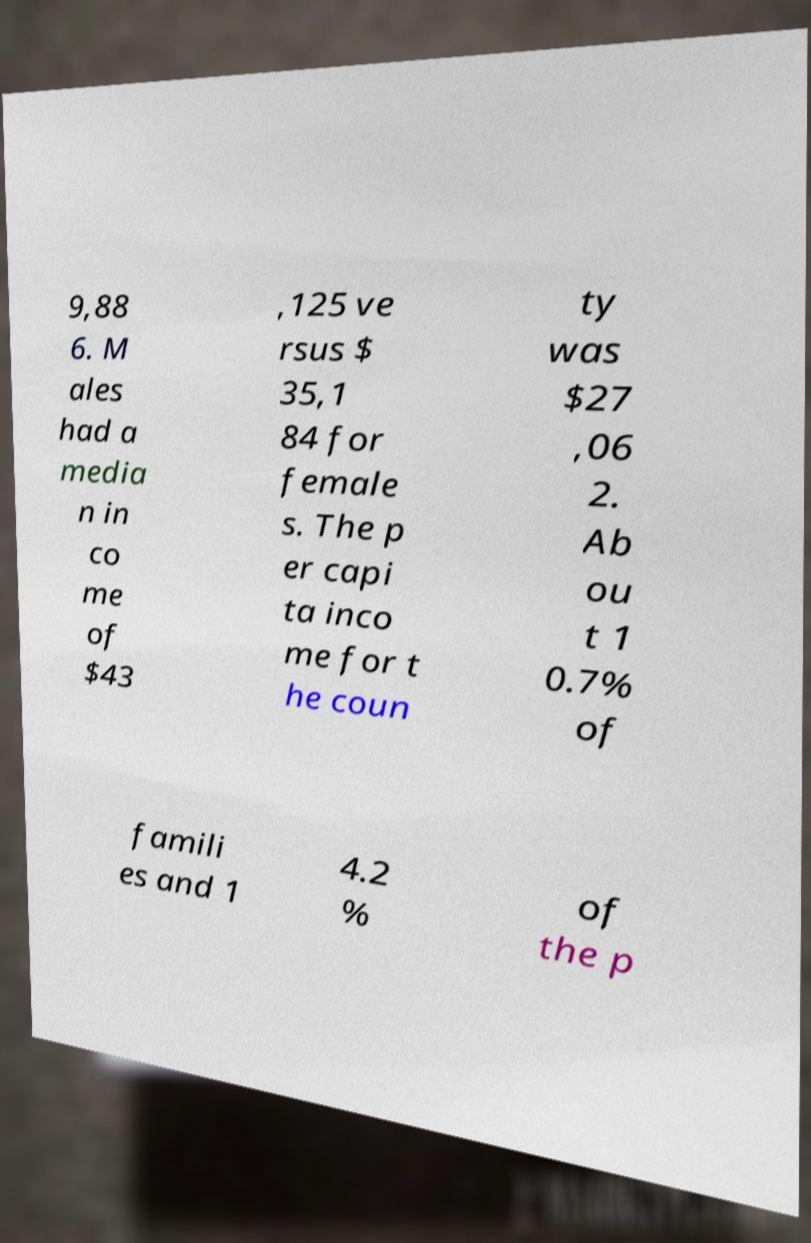Can you read and provide the text displayed in the image?This photo seems to have some interesting text. Can you extract and type it out for me? 9,88 6. M ales had a media n in co me of $43 ,125 ve rsus $ 35,1 84 for female s. The p er capi ta inco me for t he coun ty was $27 ,06 2. Ab ou t 1 0.7% of famili es and 1 4.2 % of the p 